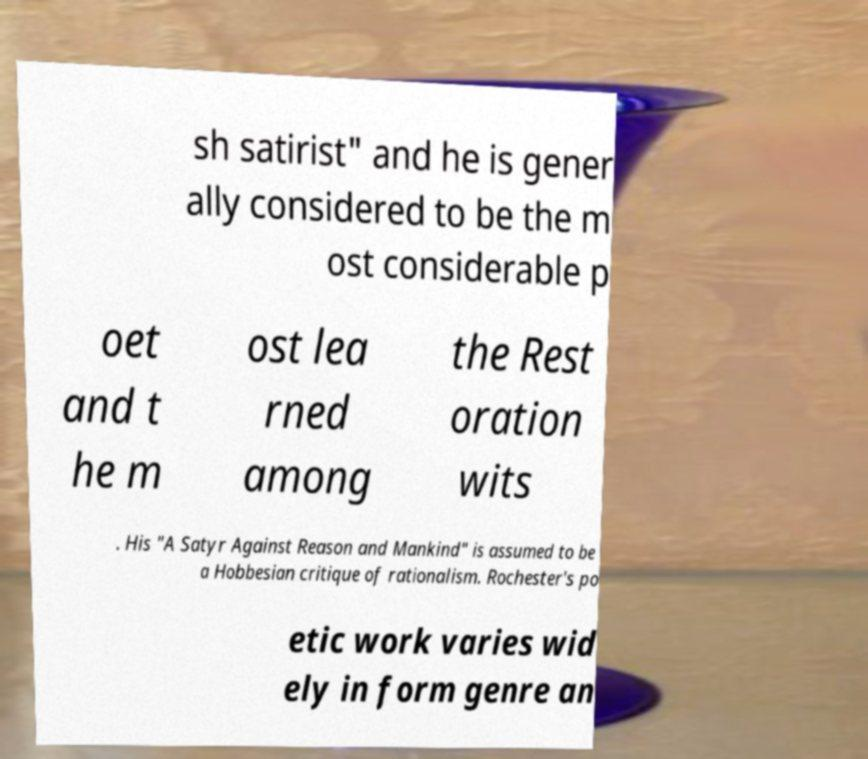Please identify and transcribe the text found in this image. sh satirist" and he is gener ally considered to be the m ost considerable p oet and t he m ost lea rned among the Rest oration wits . His "A Satyr Against Reason and Mankind" is assumed to be a Hobbesian critique of rationalism. Rochester's po etic work varies wid ely in form genre an 